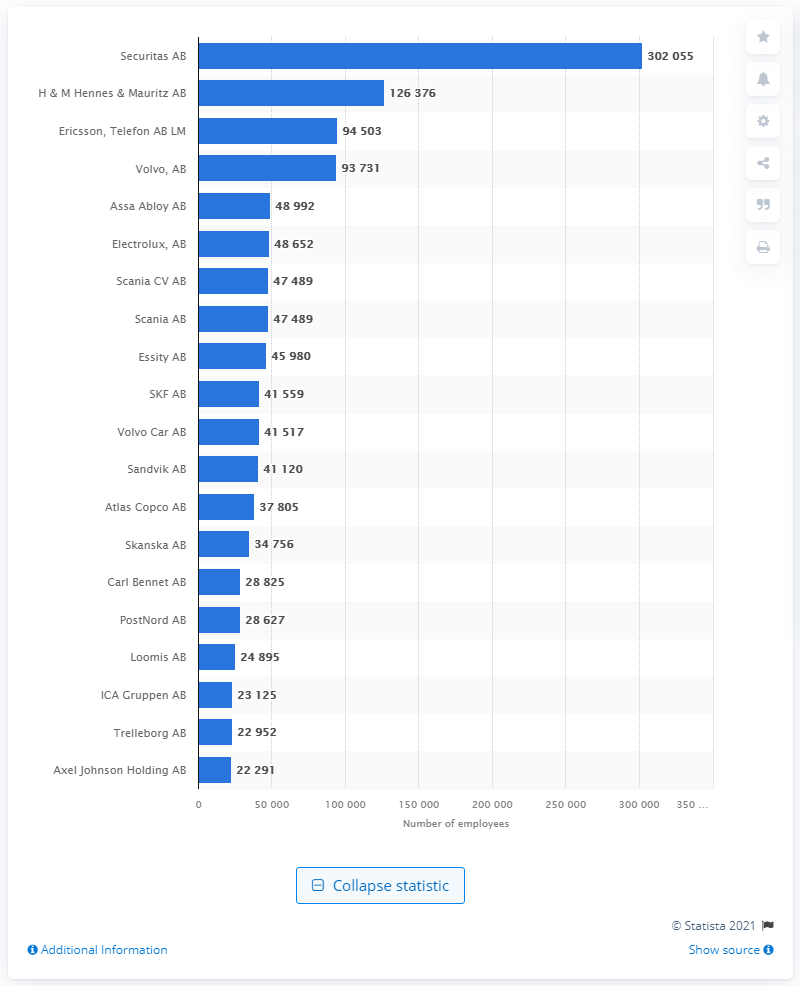Indicate a few pertinent items in this graphic. As of May 2021, Securitas employed approximately 302,055 people. The number of employees employed by H&M and Ericsson was 94,503. 